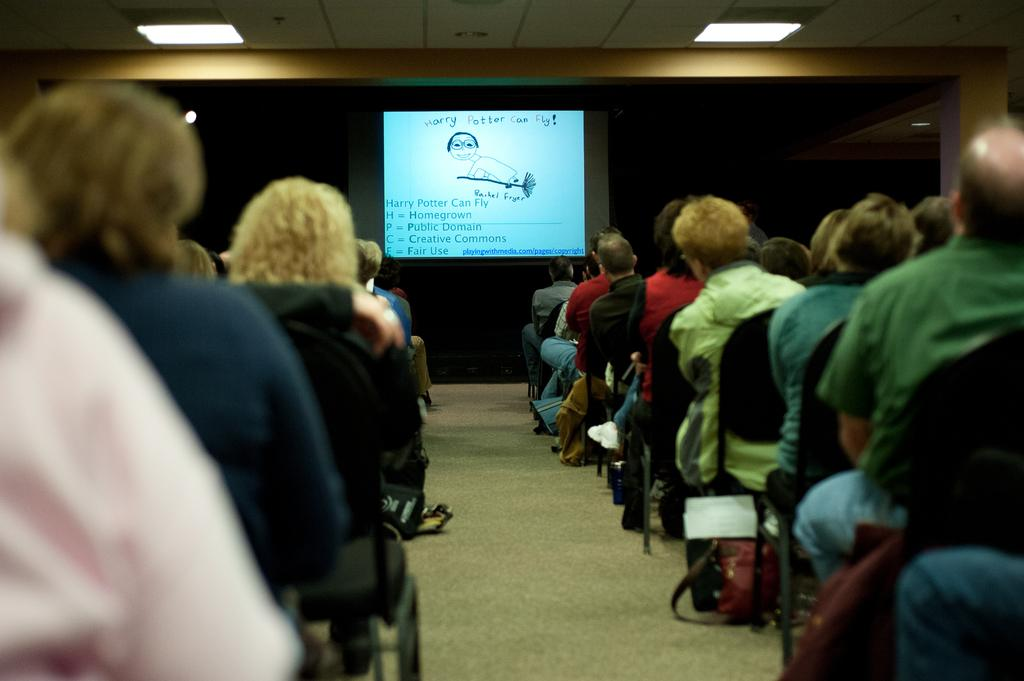What are the people in the image doing? The people in the image are sitting on chairs. What is on the floor near the chairs? There are bags on the carpet in the image. What can be seen in the background of the image? There are ceiling lights and a screen with an image and text in the background of the image. What type of paste is being used to stick the plant to the wall in the image? There is no plant or paste present in the image. 